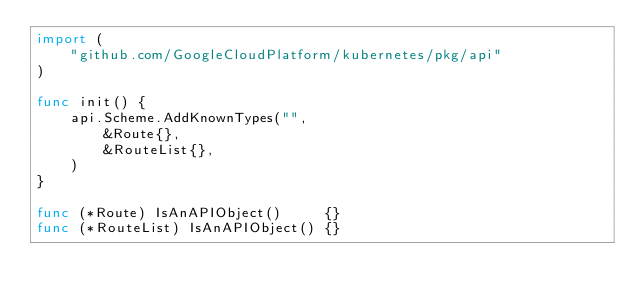<code> <loc_0><loc_0><loc_500><loc_500><_Go_>import (
	"github.com/GoogleCloudPlatform/kubernetes/pkg/api"
)

func init() {
	api.Scheme.AddKnownTypes("",
		&Route{},
		&RouteList{},
	)
}

func (*Route) IsAnAPIObject()     {}
func (*RouteList) IsAnAPIObject() {}
</code> 